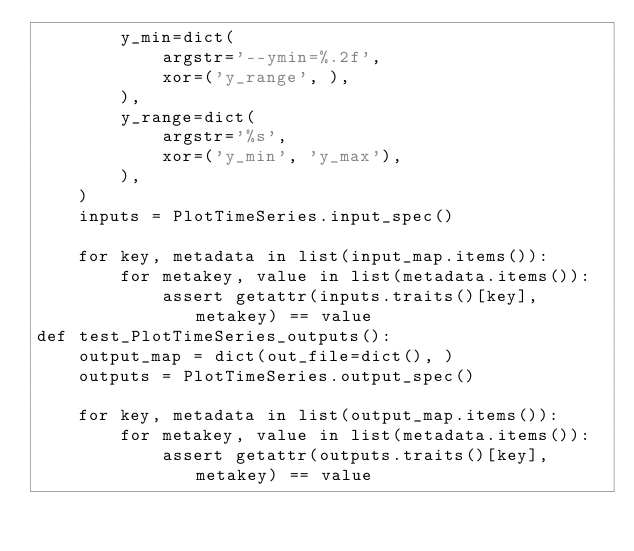Convert code to text. <code><loc_0><loc_0><loc_500><loc_500><_Python_>        y_min=dict(
            argstr='--ymin=%.2f',
            xor=('y_range', ),
        ),
        y_range=dict(
            argstr='%s',
            xor=('y_min', 'y_max'),
        ),
    )
    inputs = PlotTimeSeries.input_spec()

    for key, metadata in list(input_map.items()):
        for metakey, value in list(metadata.items()):
            assert getattr(inputs.traits()[key], metakey) == value
def test_PlotTimeSeries_outputs():
    output_map = dict(out_file=dict(), )
    outputs = PlotTimeSeries.output_spec()

    for key, metadata in list(output_map.items()):
        for metakey, value in list(metadata.items()):
            assert getattr(outputs.traits()[key], metakey) == value
</code> 